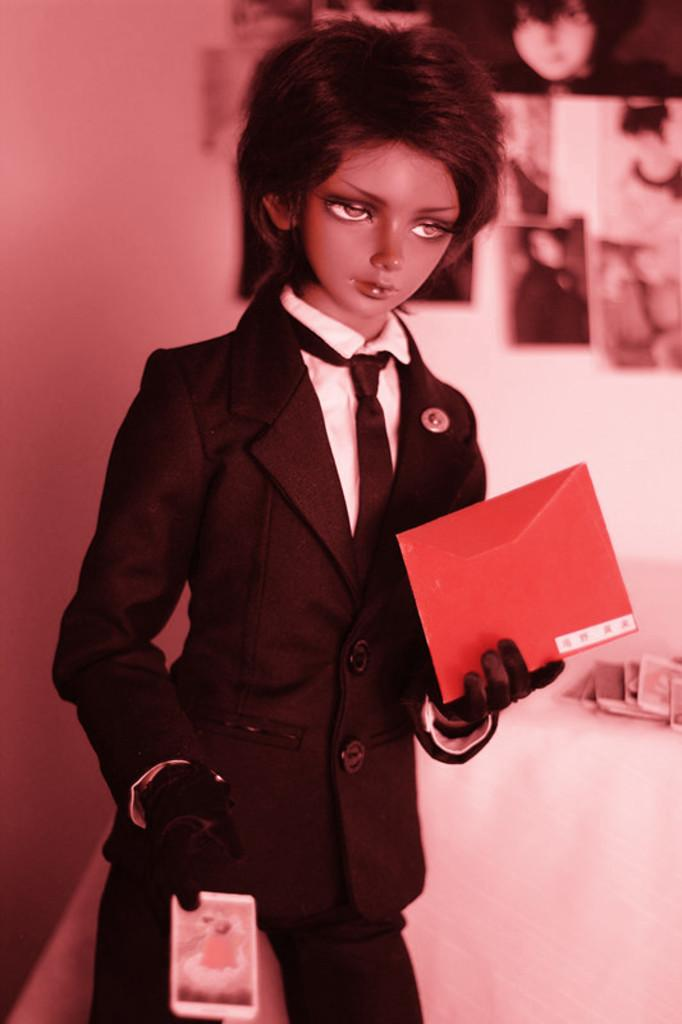What is the main subject in the front of the image? There is a doll in the front of the image. What can be seen in the background of the image? There is a wall in the background of the image. What is on the wall in the image? There are photos pasted on the wall. What number is associated with the doll's feeling of shame in the image? There is no indication of shame or any associated number in the image. 